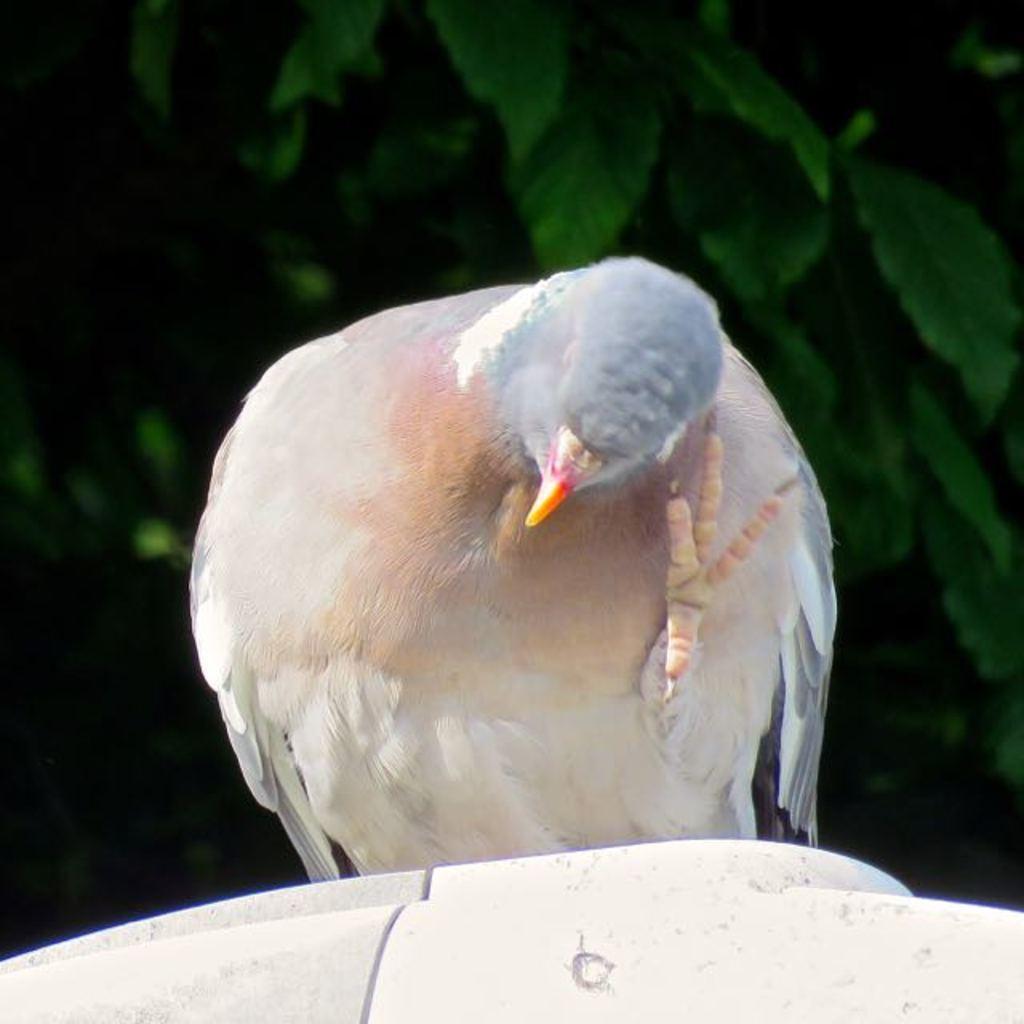Describe this image in one or two sentences. In this image I can see the bird which is in ash and brown color. It is on the white color surface. In the background I can see the trees. 